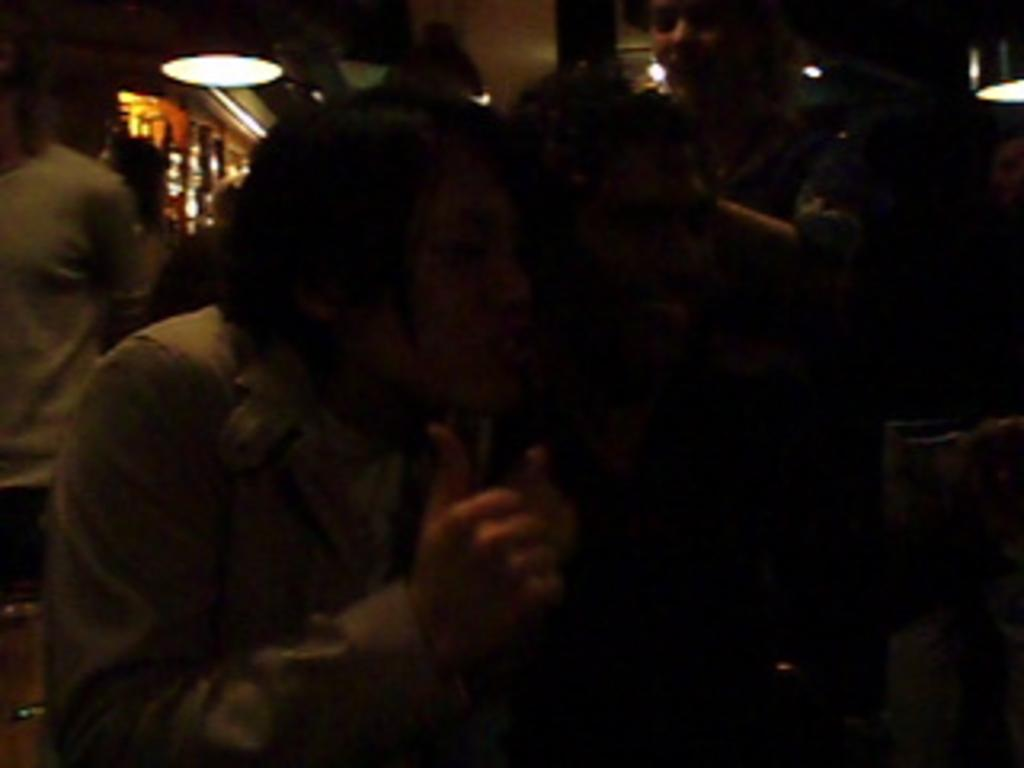Who or what is present in the image? There are people in the image. What are the people wearing? The people are wearing clothes. Can you describe any other objects or features in the image? There is a light in the image. What type of liquid can be seen flowing from the position of the office in the image? There is no liquid or office present in the image; it only features people wearing clothes and a light. 